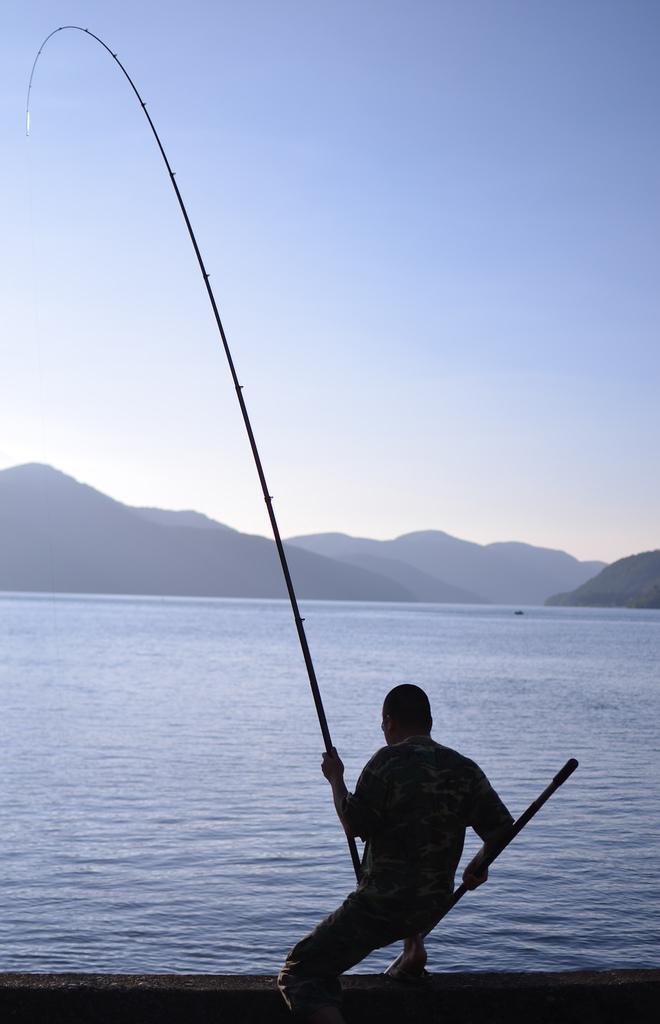How would you summarize this image in a sentence or two? In the foreground of the picture we can see a person holding a fishing net. In the middle of the picture there are hills and a water body. At the top there is sky. 